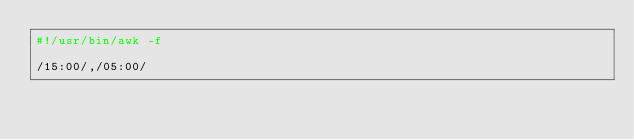<code> <loc_0><loc_0><loc_500><loc_500><_Awk_>#!/usr/bin/awk -f

/15:00/,/05:00/
</code> 